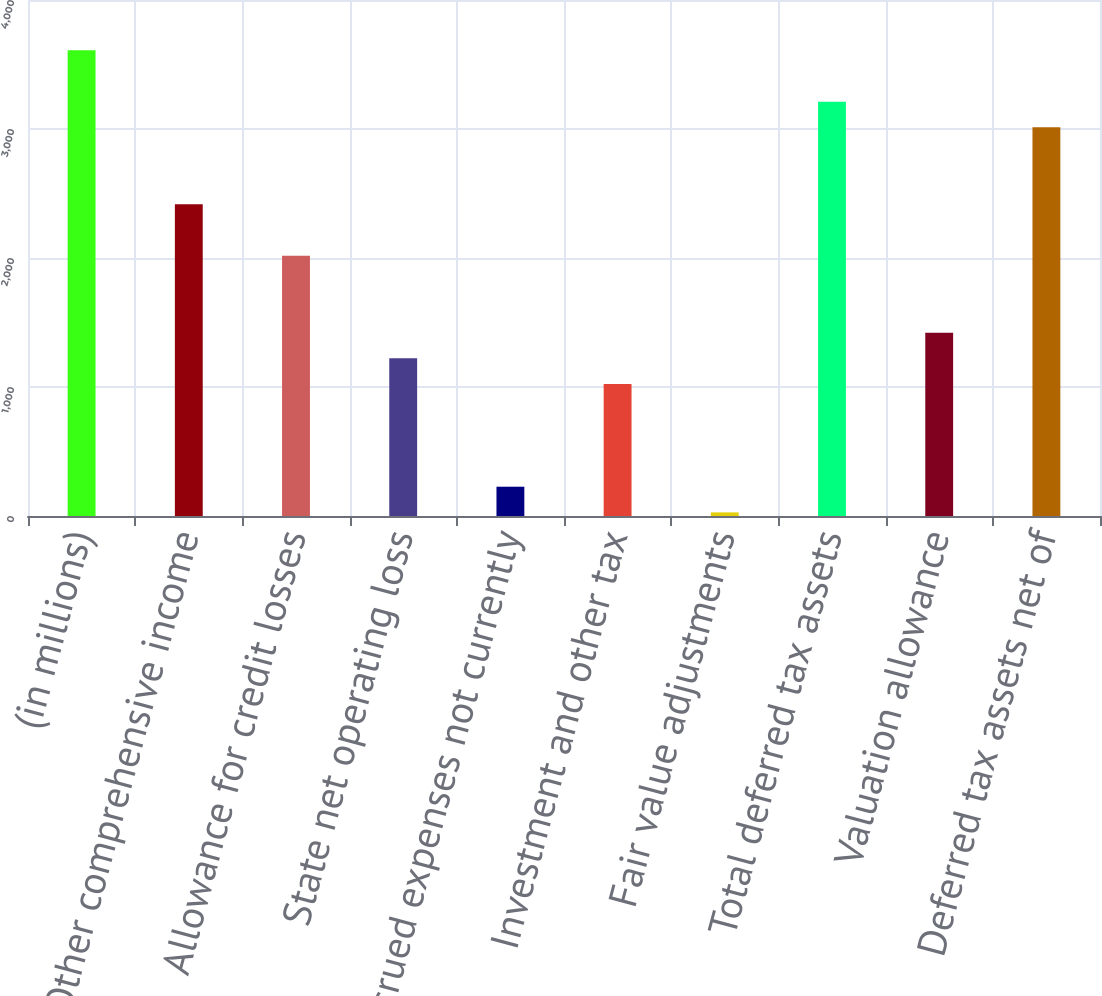Convert chart. <chart><loc_0><loc_0><loc_500><loc_500><bar_chart><fcel>(in millions)<fcel>Other comprehensive income<fcel>Allowance for credit losses<fcel>State net operating loss<fcel>Accrued expenses not currently<fcel>Investment and other tax<fcel>Fair value adjustments<fcel>Total deferred tax assets<fcel>Valuation allowance<fcel>Deferred tax assets net of<nl><fcel>3610<fcel>2416<fcel>2018<fcel>1222<fcel>227<fcel>1023<fcel>28<fcel>3212<fcel>1421<fcel>3013<nl></chart> 